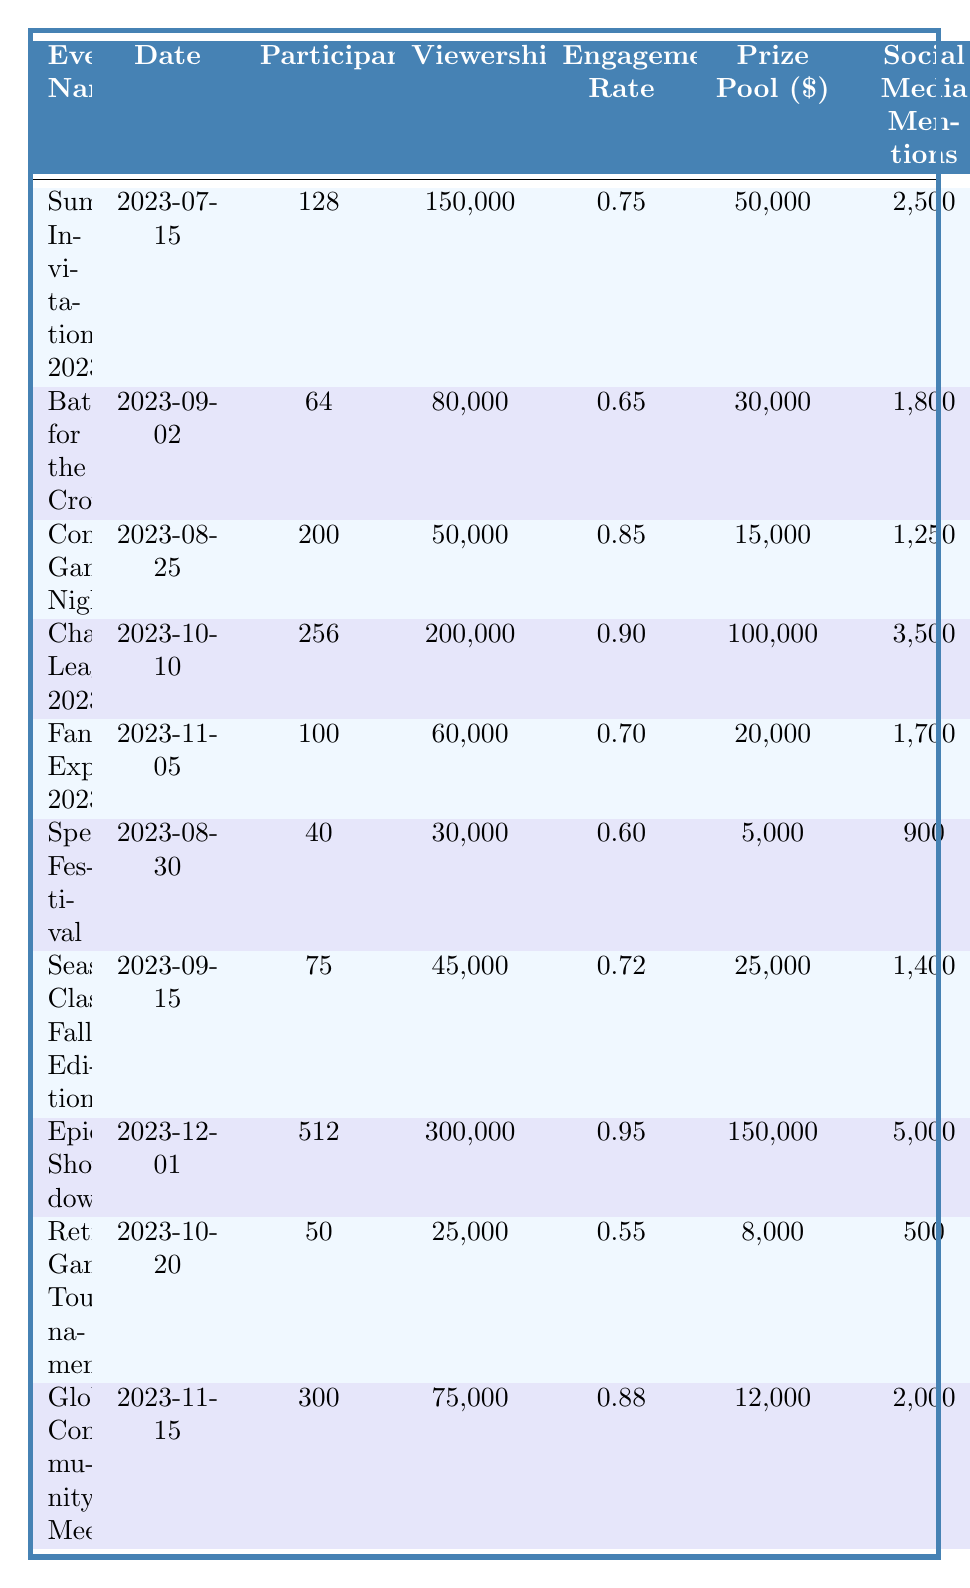What is the prize pool for the "Champions League 2023" event? The table shows that the "Champions League 2023" event has a prize pool of 100,000 dollars listed under the "Prize Pool" column for that event.
Answer: 100000 Which event had the highest viewership? The "Epic Showdown" event has the highest viewership at 300,000, which can be found in the "Viewership" column.
Answer: 300000 What is the engagement rate of the "Community Game Night"? The "Community Game Night" event shows an engagement rate of 0.85, as indicated in the "Engagement Rate" column.
Answer: 0.85 How many participants were there in total across all events? Adding the participants from each event (128 + 64 + 200 + 256 + 100 + 40 + 75 + 512 + 50 + 300) equals a total of 1,545 participants.
Answer: 1545 Is the engagement rate of "Battle for the Crown" greater than 0.7? The engagement rate for "Battle for the Crown" is 0.65, which is less than 0.7. Therefore, the answer is no.
Answer: No Which two events had the most social media mentions? "Epic Showdown" had 5,000 mentions, and "Champions League 2023" had 3,500 mentions. They are the two highest values in the "Social Media Mentions" column.
Answer: Epic Showdown and Champions League 2023 Calculate the average prize pool for the events listed. The prize pools are 50,000, 30,000, 15,000, 100,000, 20,000, 5,000, 25,000, 150,000, 8,000, and 12,000. Summing these gives 440,000 dollars. Dividing by the number of events (10) results in an average prize pool of 44,000 dollars.
Answer: 44000 What was the location for the "Speedrun Festival"? According to the table, the "Speedrun Festival" took place in Chicago, IL, as stated in the "Location" column for that event.
Answer: Chicago, IL Which event had the lowest number of participants? The "Speedrun Festival" had the lowest participation with 40 participants, which is the smallest number in the "Participants" column.
Answer: 40 Did more participants join the "Global Community Meetup" than the "Summer Invitational 2023"? The "Global Community Meetup" had 300 participants, while the "Summer Invitational 2023" had 128 participants. Since 300 is greater than 128, the statement is true.
Answer: Yes 